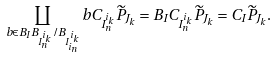Convert formula to latex. <formula><loc_0><loc_0><loc_500><loc_500>\coprod _ { b \in B _ { I } B _ { I _ { n } ^ { i _ { k } } } / B _ { I _ { i _ { n } } ^ { i _ { k } } } } b C _ { I _ { n } ^ { i _ { k } } } \widetilde { P } _ { J _ { k } } = B _ { I } C _ { I _ { n } ^ { i _ { k } } } \widetilde { P } _ { J _ { k } } = C _ { I } \widetilde { P } _ { J _ { k } } .</formula> 